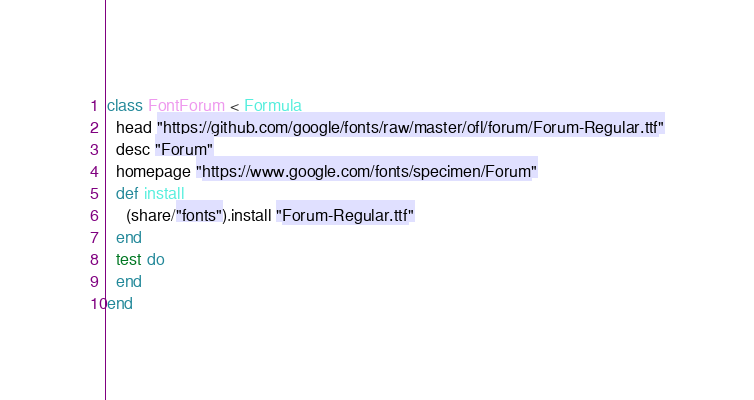<code> <loc_0><loc_0><loc_500><loc_500><_Ruby_>class FontForum < Formula
  head "https://github.com/google/fonts/raw/master/ofl/forum/Forum-Regular.ttf"
  desc "Forum"
  homepage "https://www.google.com/fonts/specimen/Forum"
  def install
    (share/"fonts").install "Forum-Regular.ttf"
  end
  test do
  end
end
</code> 